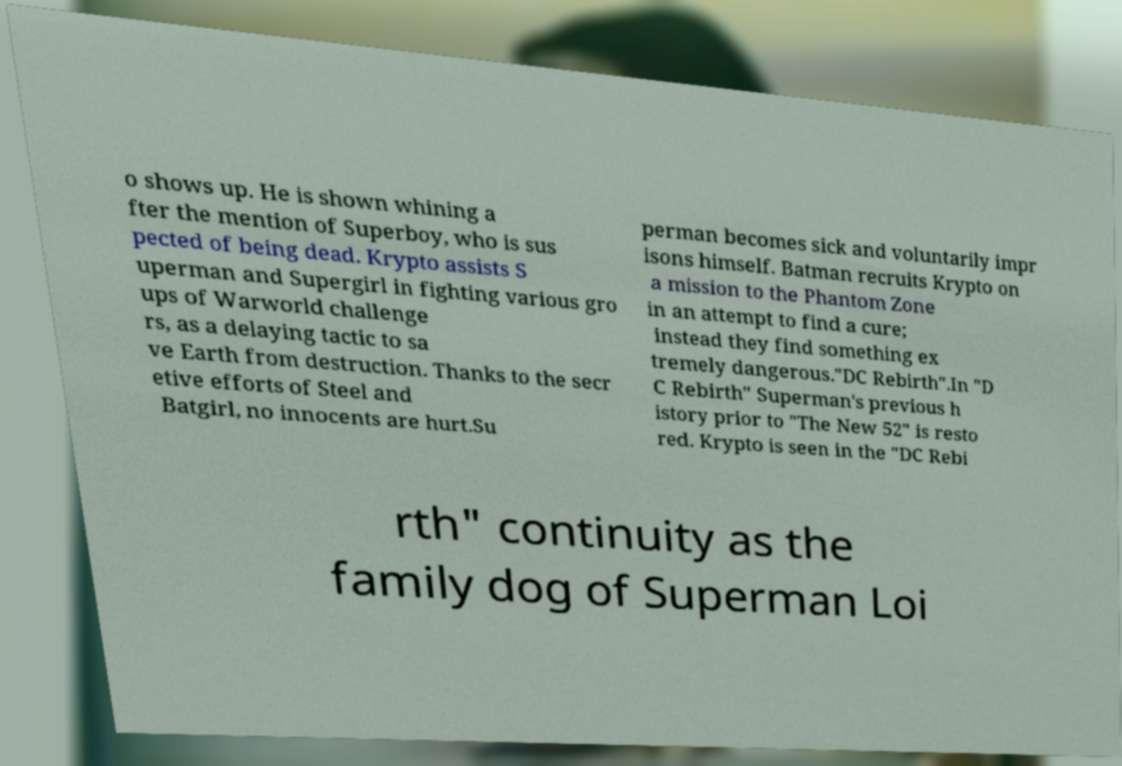I need the written content from this picture converted into text. Can you do that? o shows up. He is shown whining a fter the mention of Superboy, who is sus pected of being dead. Krypto assists S uperman and Supergirl in fighting various gro ups of Warworld challenge rs, as a delaying tactic to sa ve Earth from destruction. Thanks to the secr etive efforts of Steel and Batgirl, no innocents are hurt.Su perman becomes sick and voluntarily impr isons himself. Batman recruits Krypto on a mission to the Phantom Zone in an attempt to find a cure; instead they find something ex tremely dangerous."DC Rebirth".In "D C Rebirth" Superman's previous h istory prior to "The New 52" is resto red. Krypto is seen in the "DC Rebi rth" continuity as the family dog of Superman Loi 